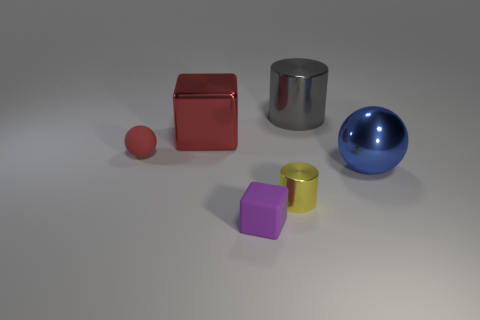The matte thing that is the same color as the metal cube is what shape?
Offer a terse response. Sphere. Are there any large things of the same color as the rubber sphere?
Your answer should be compact. Yes. How many shiny things are both to the right of the purple block and behind the yellow metal thing?
Provide a succinct answer. 2. What number of other things are there of the same size as the metal ball?
Your answer should be very brief. 2. Do the tiny matte thing right of the red metal thing and the rubber object that is left of the small purple matte cube have the same shape?
Your answer should be compact. No. How many things are tiny purple objects or big shiny things that are right of the large red thing?
Offer a terse response. 3. What is the material of the small thing that is on the left side of the yellow metallic thing and on the right side of the red rubber object?
Provide a short and direct response. Rubber. There is a large ball that is the same material as the red cube; what color is it?
Give a very brief answer. Blue. How many objects are large gray things or cylinders?
Your answer should be compact. 2. There is a red sphere; does it have the same size as the cylinder behind the red sphere?
Offer a very short reply. No. 